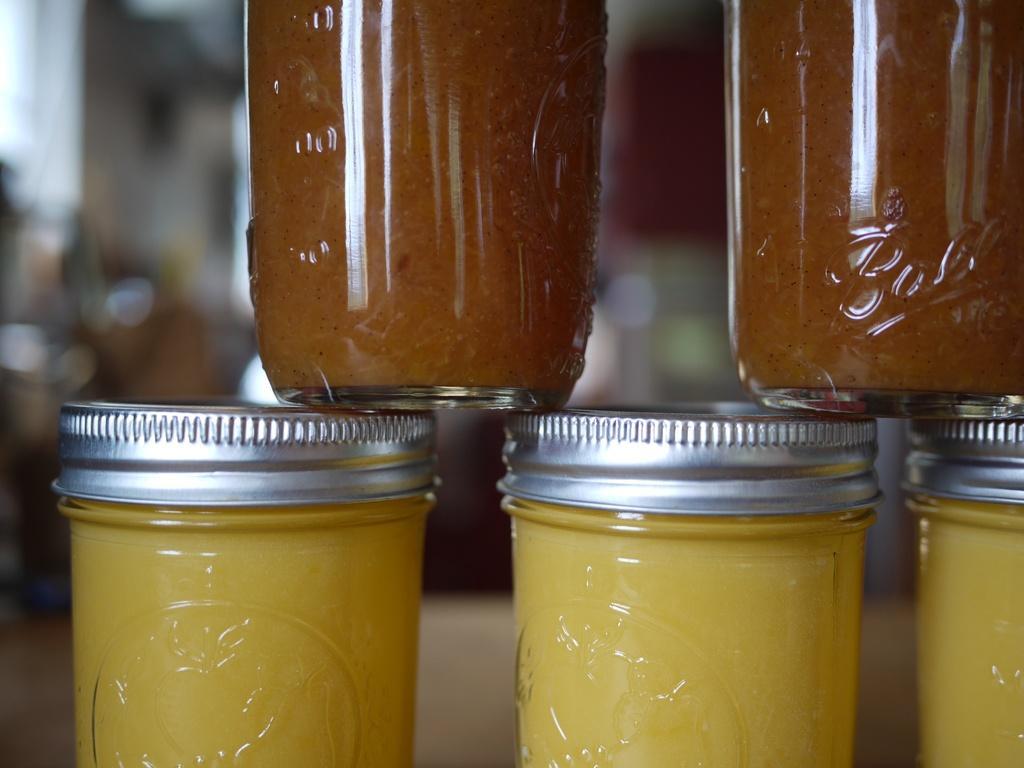Can you describe this image briefly? In this image I can see 5 glass jars with silver lids. The background is blurred. 